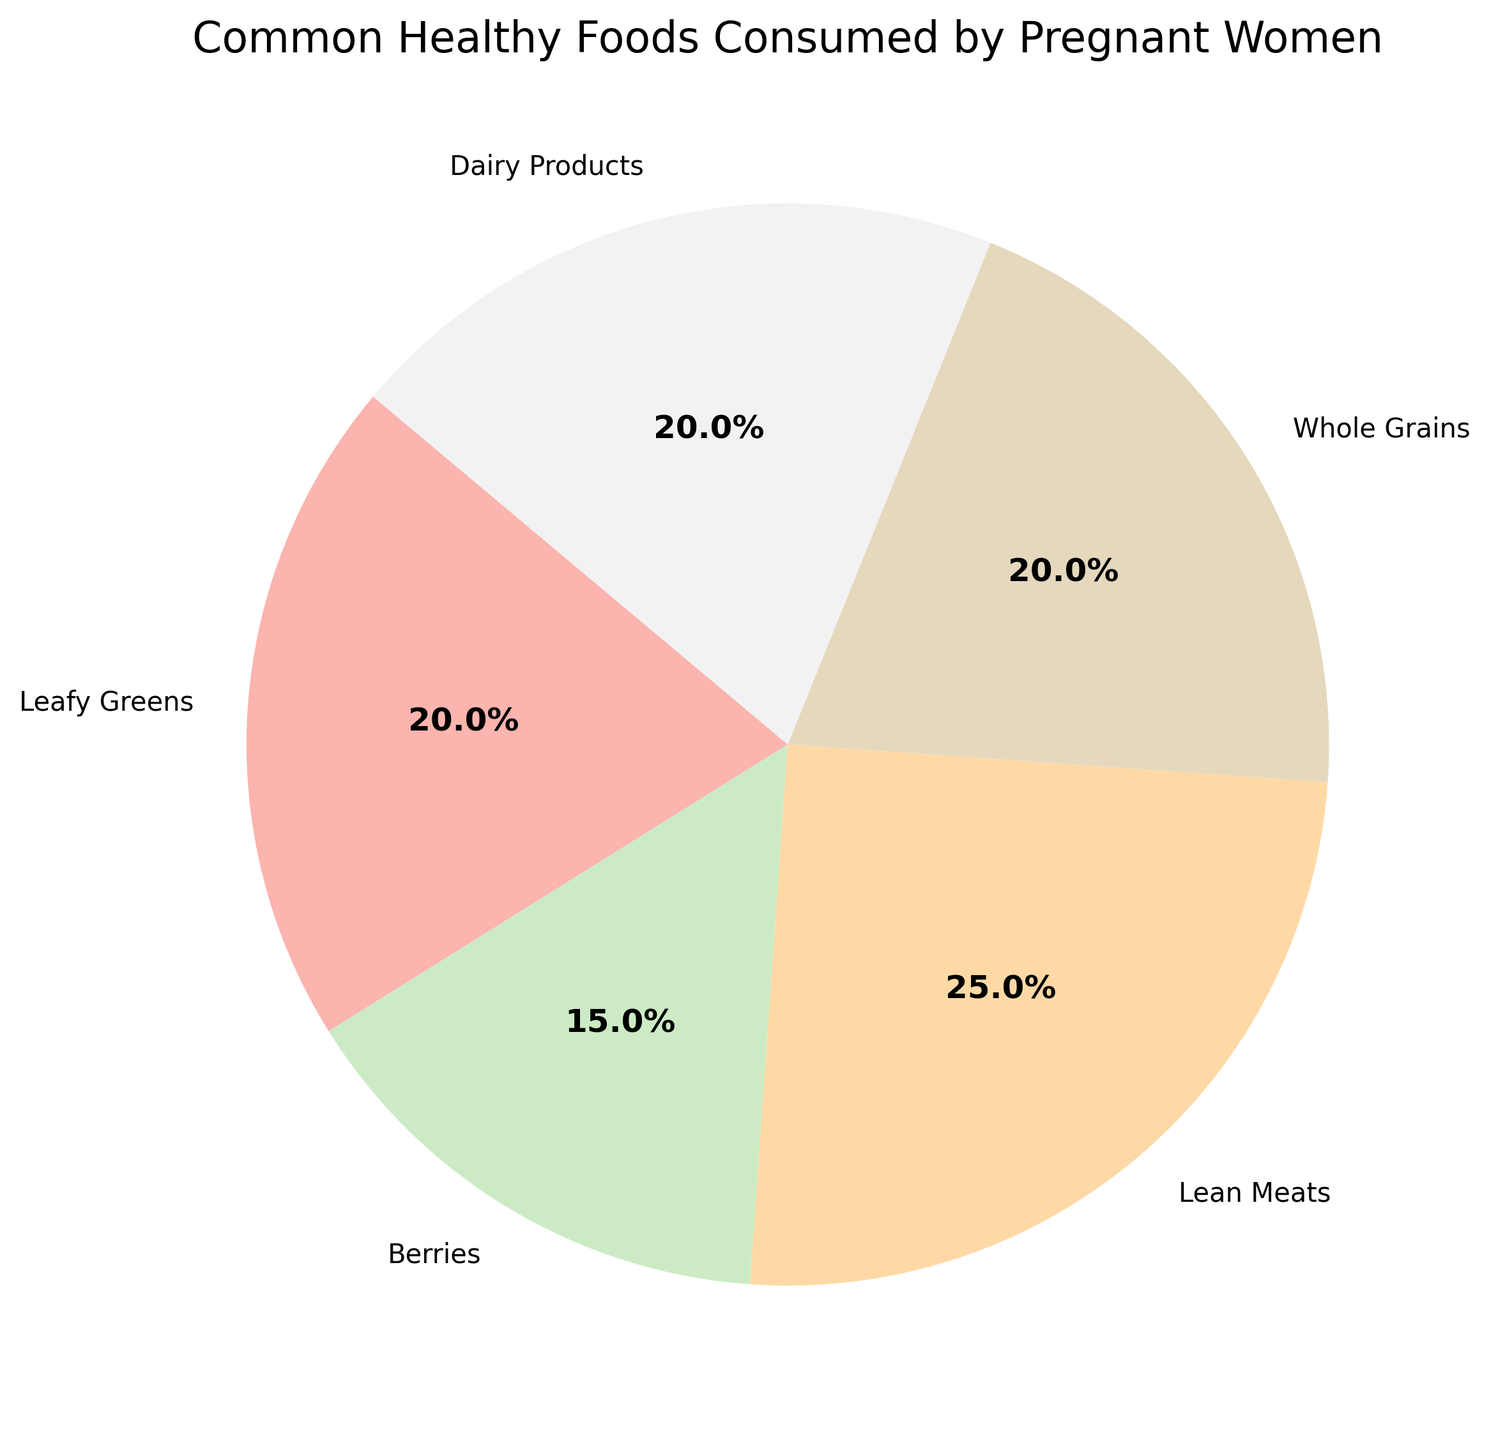what category has the highest percentage in the pie chart? By looking at the pie chart, we identify the segment with the largest size. The Lean Meats segment appears to be the largest, thus having the highest percentage.
Answer: Lean Meats Which category has the smallest share in the pie chart? By observing the sizes of the segments, the Berries segment seems to be the smallest, indicating it has the smallest share among the categories listed.
Answer: Berries Do Leafy Greens and Whole Grains together constitute more than 50% of the chart? Add the percentages of Leafy Greens (20%) and Whole Grains (20%) and see if they're more than 50%. 20 + 20 = 40, which is less than 50%.
Answer: No Which categories have an equal percentage distribution? By examining the pie chart, we notice that Leafy Greens, Whole Grains, and Dairy Products all appear to have equal sizes, each constituting 20% of the pie chart.
Answer: Leafy Greens, Whole Grains, Dairy Products What is the difference in percentage between Lean Meats and Berries? Subtract the percentage for Berries (15%) from the percentage for Lean Meats (25%). 25 - 15 = 10.
Answer: 10 What is the combined percentage of categories that exceed 20%? Only Lean Meats has a percentage exceeding 20%, which is 25%.
Answer: 25 Are Dairy Products included in more than one-fifth of the total chart? Compare the percentage of Dairy Products (20%) with one-fifth (20%) of the chart. Since 20% is equal to one-fifth, Dairy Products constitute exactly one-fifth and not more.
Answer: No Which category is represented in a yellow tone in the pie chart? By associating the listed colors with their corresponding categories visually from the pie chart, we identify the segment likely depicted in yellow as Leafy Greens.
Answer: Leafy Greens 